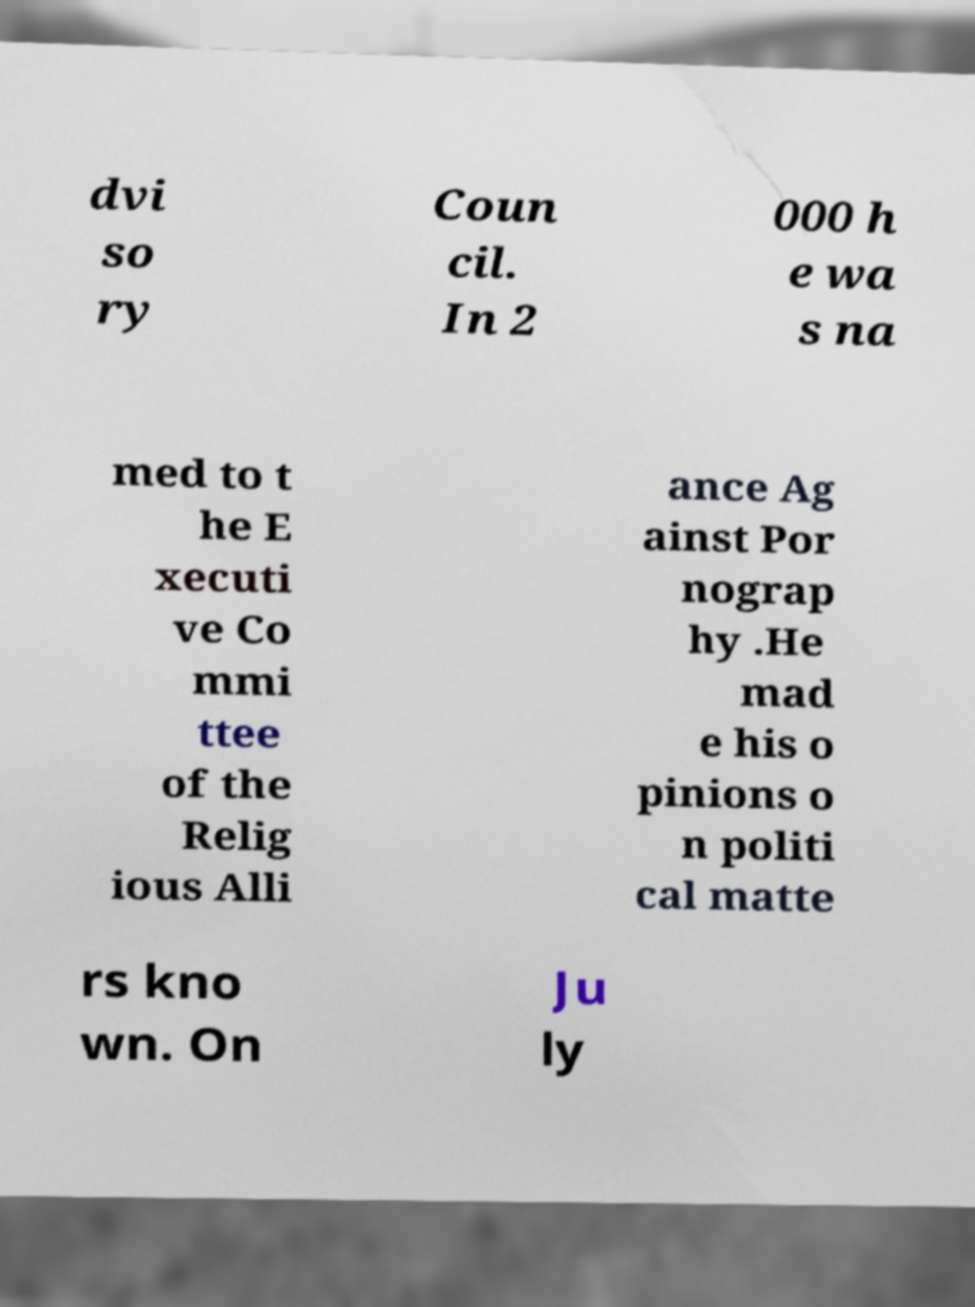What messages or text are displayed in this image? I need them in a readable, typed format. dvi so ry Coun cil. In 2 000 h e wa s na med to t he E xecuti ve Co mmi ttee of the Relig ious Alli ance Ag ainst Por nograp hy .He mad e his o pinions o n politi cal matte rs kno wn. On Ju ly 